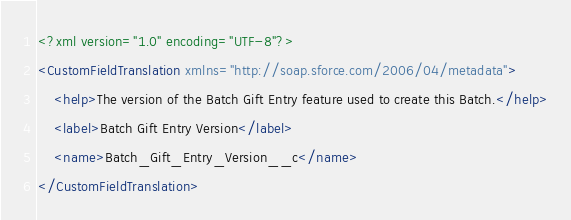<code> <loc_0><loc_0><loc_500><loc_500><_XML_><?xml version="1.0" encoding="UTF-8"?>
<CustomFieldTranslation xmlns="http://soap.sforce.com/2006/04/metadata">
    <help>The version of the Batch Gift Entry feature used to create this Batch.</help>
    <label>Batch Gift Entry Version</label>
    <name>Batch_Gift_Entry_Version__c</name>
</CustomFieldTranslation>
</code> 